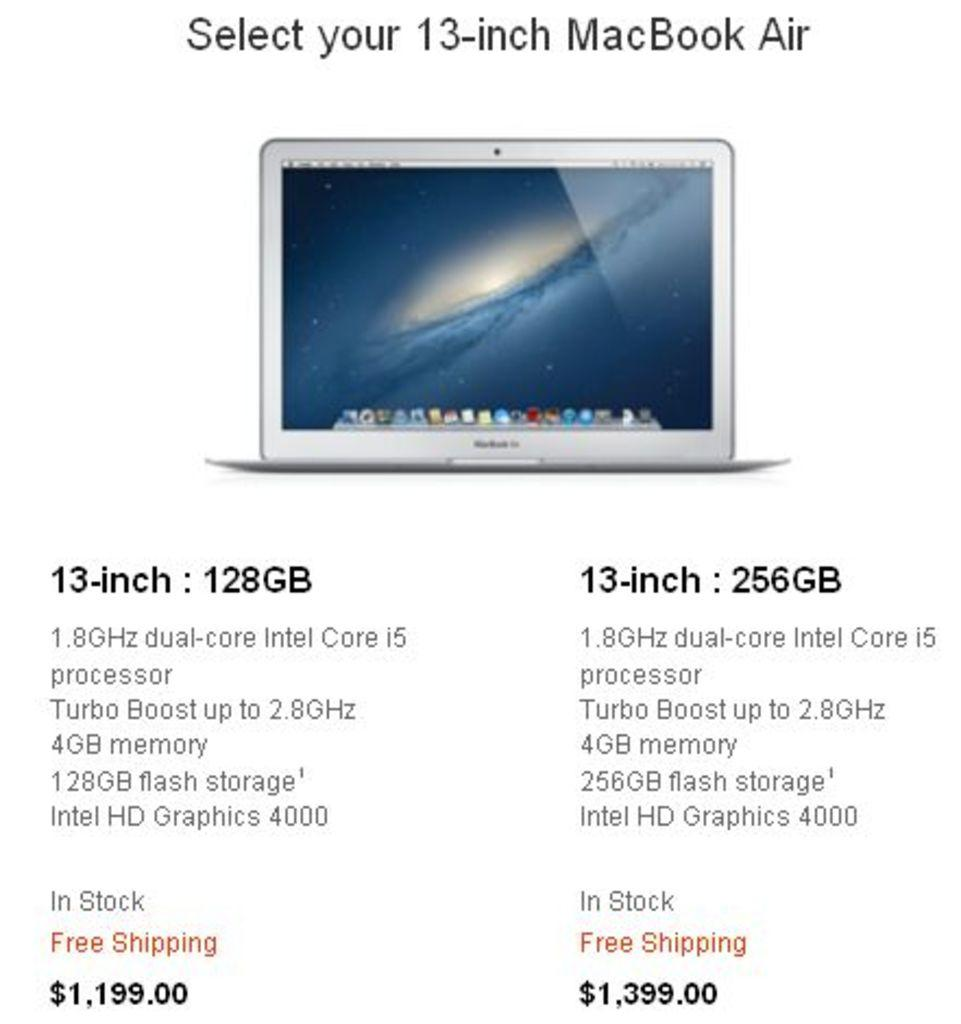<image>
Write a terse but informative summary of the picture. Information about a 13-inch Macbook Air including the price. 